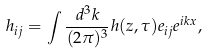<formula> <loc_0><loc_0><loc_500><loc_500>h _ { i j } = \int \frac { d ^ { 3 } k } { ( 2 \pi ) ^ { 3 } } h ( z , \tau ) e _ { i j } e ^ { i k x } ,</formula> 